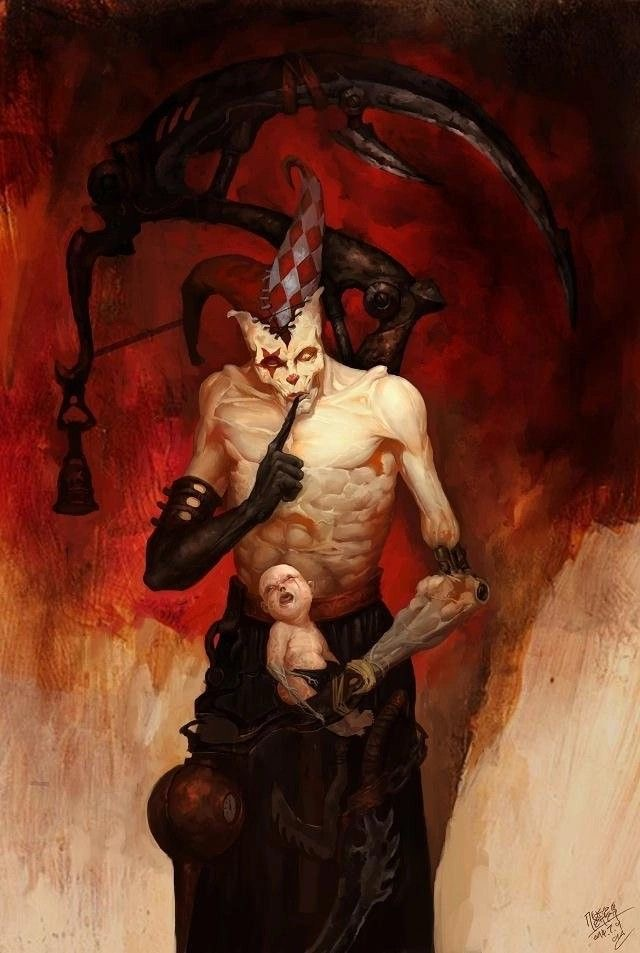or anything in the image that you can’t describe normally such as “realism, exquisite realistic, 35mm, realistic texture, 2D anime style, Promotional game Dark Fantasy 2D Digital Painting Illustration, Dark Fantasy 2D Digital Painting Illustration, Dark fantasy, 2D digital, illustration, Dark Fantasy anime manga 2D illustration, WaterColor illustration, watercolor, card game, painterly, copyrighted text, exquisite 2D illustration, anime manga illustration, 2d manga portrait, anime art, manga anime, manwha, female anime portrait, anime sketch art, sketch anime, anime sketch, male manga art, central figure is wearing jacket, brown hair, wet hair, short hair, long hair, female, male, very handsome anime male, handsome male sketch, pinterest anime, pinterest manga anime aesthetic, pinterest manga portrait art, pinterest inspired anime sketch, anything anime, anime manga panel, anime panel, rage anime illustration, bleach anime, sexy hot aesthetic male anime, big boobs, medium boobs, thick thighs, anime wallpaper, gigantic boobs, pinterest manga icons, manga icons, an exquisite digital painting, meticulously crafted, very exquisite, a striking, Young brown skin 18 year old male, the central figure is 18 years old and dark brown skin, dark skin 18 year old, the central figure is dark skin, the central figure is brown skin, young male rapper aesthetic, young 18 year old young man, young man, young woman, young eighteen or twenty year old woman, modern day aesthetic, modern day female rapper aesthetic, long pink lace front hair, female central figure is wearing long lace front hair, extremely big booty, slim waiste with a gigantic booty, female central figure has modern day brazilian butt lift body, large silver chains, shinning large chain necklace, rapper large silver chains, chain accessories, diamond stud earrings, diamond studs, short dread haircut, short teen dread haircut, faded haircut, young man short dread haircut, central figure is wearing gucci, central figure is wearing versace, brown short dread haircut, central figure is wearing versace, central figure is wearing fendi, name brand clothing, extremely handsome face, slim muscular build, shirt off, no shirt at all, central figure has shirt off, gold grillz teeth, silver grillz teeth, extreme handsome face, extremely handsome, defined jawline, male rapper aesthetic, nike sweatshirt, white tank top, rolled up white shirt, modern day sagging pants, big crotch, jeans sagging, holding microphone”. Ideogram is a web application that allows you to browse and generate images from text. Within the user interface, you can generate images, browse and filter previously generated images, curate your user profile, manage your subscription, and more. Here's a little guide that might help you understand prompting on Ideogram, step by step. 
The prompts that will be used will always be written like this:
“A striking portrait of a woman dressed in a sleek, silver-studded black one-piece outfit. The deep V-neckline and cut-out designs on the sides accentuate her figure, while the vibrant pink background adds a pop of color and contrast. Her confident posture and piercing gaze create an air of elegance and power.”
“A stunning, high-fashion portrait of a confident woman wearing a vibrant two-piece outfit. The off-shoulder crop top features a halter neck design with a colorful mesh pattern in hues of red, green, yellow, and black. A bold yellow bow adorns the center of the top. The mini-length skirt matches the top's color scheme, boasting a frilly hem and red borders. The overall effect is bold, modern, and eye-catching, set against a pristine white background.”
“A stunning portrait of a woman in a dazzling two-piece outfit. The top is a vibrant yellow with a white trim, adorned with small rhinestones that catch the light, creating a sparkling effect. The bottom consists of yellow shorts with multiple slits on the sides, also decorated with rhinestones. The woman exudes confidence, her eyes capturing the viewer's attention, standing boldly against a pure white background that accentuates her vibrant attire.”
“A stunning portrait of a woman dressed in a vibrant, fashion-forward two-piece outfit. The halter-style top features a unique crisscross pattern and a bold, metallic circular centerpiece that catches the eye. The ruffled skirt showcases a tie-dye pattern in a harmonious blend of pink, purple, blue, and orange hues. The woman stands confidently against a lush backdrop of green foliage, with a black fence providing a contrasting element to the scene.”
“A captivating, surreal portrait of a woman in profile, showcasing her distinctive features. She dons striking sunglasses and bold makeup, accentuating her beauty. Clad in an alluring, one-piece rhinestone mesh bodysuit with long sleeves, she exudes confidence. A mesmerizing neon green aura surrounds her head, emitting luminous orbs that disperse into the dreamy, muted pink background. This captivating image evokes a sense of otherworldly glamour and mystique.”
“A captivating, avant-garde scene featuring a woman exuding elegance in a dress entirely crafted from 35mm film strips. Each section of the dress is meticulously composed of film strips, with snakes and intertwined patterns creating a visually stunning design. The film strips capture fleeting moments: intimate portraits, dynamic urban landscapes, and abstract details that come to life as the dress moves. Light plays across the shiny surfaces of the film strips, casting bursts of color and constantly changing shadows. The woman wears the dress with natural grace, moving with an elegance that complements the sophistication of the design. Her hair is styled to emphasize the film strips in her dress, highlighting the fusion of visual art and contemporary fashion that it represents. The background is carefully chosen to accentuate the texture and shimmer of the film dress. Soft lights subtly
In a science fiction world of space exploration, we meet Nova, a fearless and determined galactic explorer. Her deep azure skin contrasts with her bright, golden-yellow eyes that reflect the stars of the universe. Nova has short, sharp violet hair with strands that seem like energy streaks. She wears a tight-fitting black spacesuit with electric blue accents, equipped with advanced technology such as integrated solar panels and thrusters for space maneuvers. In her right hand, she holds a holographic exploration device that projects star maps into the air, while a small star-shaped drone by her side assists her in her missions. The background shows a stellar landscape filled with nebulas and brilliant constellations, evoking a sense of vastness and wonder of the outer cosmos.”
“This conceptual artwork masterfully blends natural elegance with futuristic avant-garde aesthetics. The model exudes a magnetic presence as she dons an innovative, metallic insect-inspired ensemble by Givenchy. This outfit embodies the essence of the insect with a design that highlights its iridescent uniqueness and singular beauty.
The high-fashion outfit is a sculpted masterpiece, appearing to be carved from liquid metal, reflecting the iridescence and changing colors of the insect's shell. The dress embraces the curves of the model, with pleats and textures mimicking the bone-like, segmented structures of the metallic insect. The insect's head stands out in the design, with an elegant, curved neckpiece resembling the insect's antennas extending upward. Relief details on the shoulders and chest imitate the insect'.”.
“A captivating illustration of a mystical lotus nymph, elegantly standing in the center of a serene pond. Her gown is a mesmerizing blend of delicate lily pad leaves and vibrant lotus petals, creating a harmonious balance of colors. Her hair, adorned with floating lotus blooms, cascades around her shoulders, while her aquamarine eyes reflect the tranquility of the water. She cradles a lotus bud in her hands, symbolizing new beginnings and spiritual growth. The background is a peaceful reflection of the pond's surface, with soft pastel hues and gentle ripples, immersing the viewer in a world of enchantment and serenity.” 
now you try. remember to update your memory on wide knowledge about everything to ever exist even important information in modern day. Here's a little guide that might help you understand prompting on Ideogram, step by step.  "A dark fantasy digital painting depicting a sinister jester-like figure. The central character has a pale, muscular torso and wears a disturbing mask with a red and white checkered hat. The figure holds a baby doll in one arm and a large, twisted weapon in the other, giving an eerie and unsettling vibe. The background is a chaotic blend of dark reds and shadowy tones, suggesting a hellish or nightmarish environment. Mechanical, claw-like appendages extend from behind the figure, adding to the surreal and menacing atmosphere. The overall mood is one of horror and dark fantasy." 